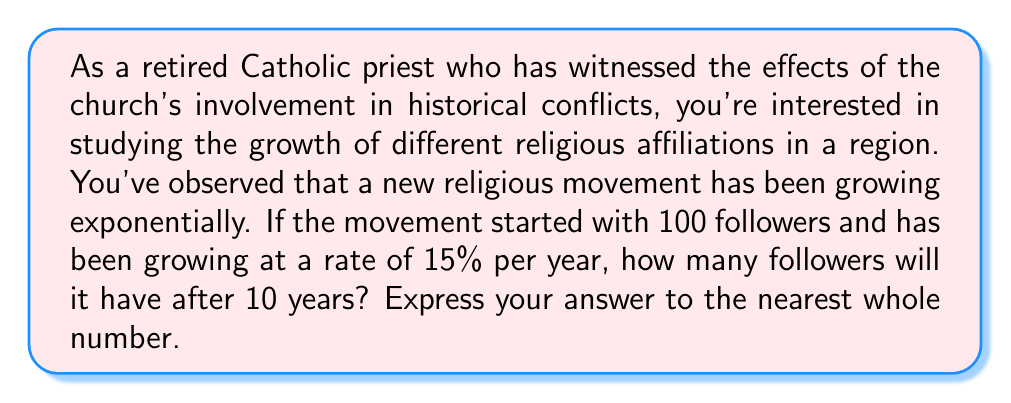Help me with this question. To solve this problem, we'll use the exponential growth model:

$$A = P(1 + r)^t$$

Where:
$A$ = Final amount
$P$ = Initial principal (starting amount)
$r$ = Growth rate (as a decimal)
$t$ = Time period

Given:
$P = 100$ (initial followers)
$r = 0.15$ (15% growth rate)
$t = 10$ years

Let's substitute these values into our equation:

$$A = 100(1 + 0.15)^{10}$$

Now, let's solve step-by-step:

1) First, calculate $(1 + 0.15)$:
   $1 + 0.15 = 1.15$

2) Now our equation looks like:
   $$A = 100(1.15)^{10}$$

3) Calculate $(1.15)^{10}$:
   $(1.15)^{10} \approx 4.0456$

4) Multiply by 100:
   $100 * 4.0456 = 404.56$

5) Round to the nearest whole number:
   $404.56 \approx 405$

Therefore, after 10 years, the religious movement will have approximately 405 followers.
Answer: 405 followers 